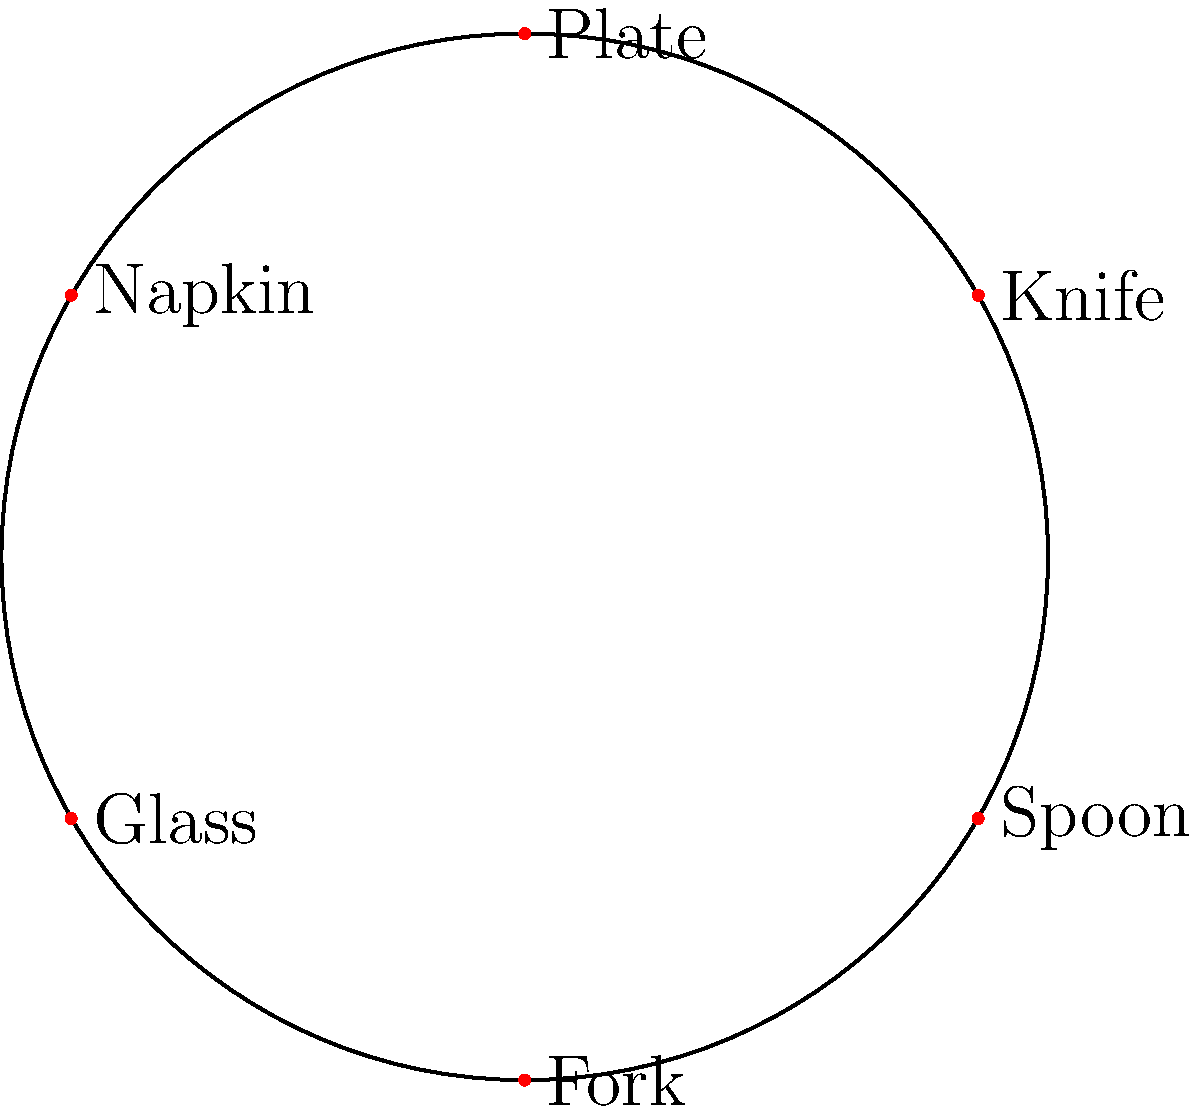In a formal dinner setting, which item should be placed directly to the right of the plate? To determine the correct placement of utensils in a formal table setting, follow these steps:

1. Identify the plate's position: In the diagram, the plate is at the top (12 o'clock position).

2. Understand the general rule: Utensils are placed in the order of use, from the outside in.

3. Recall the traditional placement:
   - Forks go to the left of the plate
   - Knives and spoons go to the right of the plate
   - Glasses are placed above and to the right of the plate
   - Napkins can be placed to the left of the forks or on the plate

4. Examine the right side of the plate:
   - The item closest to the plate on the right is the knife
   - The spoon is placed to the right of the knife

5. Consider the function: The knife is used more frequently than the spoon and is essential for cutting food, so it's placed closest to the plate.

Therefore, in a formal dinner setting, the knife should be placed directly to the right of the plate.
Answer: Knife 